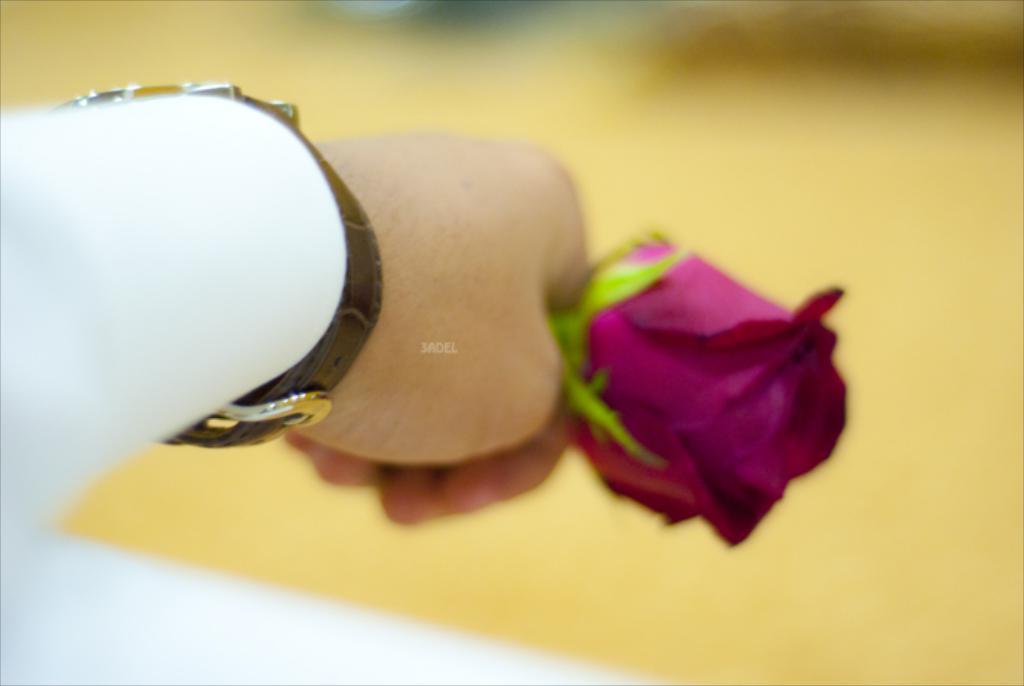In one or two sentences, can you explain what this image depicts? On the left side, there is a person in white color shirt, wearing a watch and holding a rose flower. And the background is blurred. 